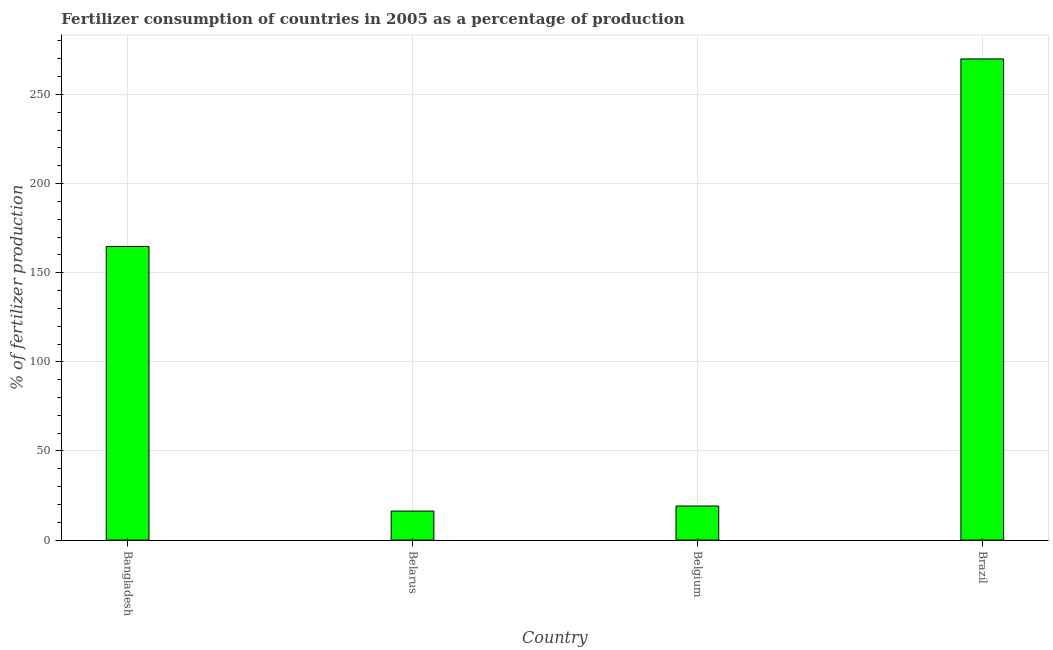What is the title of the graph?
Your answer should be compact. Fertilizer consumption of countries in 2005 as a percentage of production. What is the label or title of the X-axis?
Ensure brevity in your answer.  Country. What is the label or title of the Y-axis?
Your answer should be compact. % of fertilizer production. What is the amount of fertilizer consumption in Bangladesh?
Provide a short and direct response. 164.73. Across all countries, what is the maximum amount of fertilizer consumption?
Ensure brevity in your answer.  269.94. Across all countries, what is the minimum amount of fertilizer consumption?
Your answer should be compact. 16.29. In which country was the amount of fertilizer consumption minimum?
Provide a succinct answer. Belarus. What is the sum of the amount of fertilizer consumption?
Your answer should be compact. 470.08. What is the difference between the amount of fertilizer consumption in Belgium and Brazil?
Make the answer very short. -250.82. What is the average amount of fertilizer consumption per country?
Your answer should be compact. 117.52. What is the median amount of fertilizer consumption?
Provide a short and direct response. 91.92. What is the ratio of the amount of fertilizer consumption in Belgium to that in Brazil?
Your answer should be very brief. 0.07. Is the amount of fertilizer consumption in Belgium less than that in Brazil?
Offer a terse response. Yes. What is the difference between the highest and the second highest amount of fertilizer consumption?
Offer a very short reply. 105.21. Is the sum of the amount of fertilizer consumption in Bangladesh and Brazil greater than the maximum amount of fertilizer consumption across all countries?
Your answer should be very brief. Yes. What is the difference between the highest and the lowest amount of fertilizer consumption?
Provide a short and direct response. 253.65. Are all the bars in the graph horizontal?
Ensure brevity in your answer.  No. How many countries are there in the graph?
Offer a very short reply. 4. What is the % of fertilizer production in Bangladesh?
Provide a succinct answer. 164.73. What is the % of fertilizer production of Belarus?
Ensure brevity in your answer.  16.29. What is the % of fertilizer production of Belgium?
Provide a succinct answer. 19.12. What is the % of fertilizer production in Brazil?
Offer a very short reply. 269.94. What is the difference between the % of fertilizer production in Bangladesh and Belarus?
Your answer should be very brief. 148.44. What is the difference between the % of fertilizer production in Bangladesh and Belgium?
Give a very brief answer. 145.61. What is the difference between the % of fertilizer production in Bangladesh and Brazil?
Give a very brief answer. -105.21. What is the difference between the % of fertilizer production in Belarus and Belgium?
Make the answer very short. -2.83. What is the difference between the % of fertilizer production in Belarus and Brazil?
Offer a very short reply. -253.65. What is the difference between the % of fertilizer production in Belgium and Brazil?
Offer a terse response. -250.82. What is the ratio of the % of fertilizer production in Bangladesh to that in Belarus?
Give a very brief answer. 10.11. What is the ratio of the % of fertilizer production in Bangladesh to that in Belgium?
Provide a short and direct response. 8.62. What is the ratio of the % of fertilizer production in Bangladesh to that in Brazil?
Keep it short and to the point. 0.61. What is the ratio of the % of fertilizer production in Belarus to that in Belgium?
Provide a short and direct response. 0.85. What is the ratio of the % of fertilizer production in Belarus to that in Brazil?
Provide a short and direct response. 0.06. What is the ratio of the % of fertilizer production in Belgium to that in Brazil?
Your answer should be very brief. 0.07. 